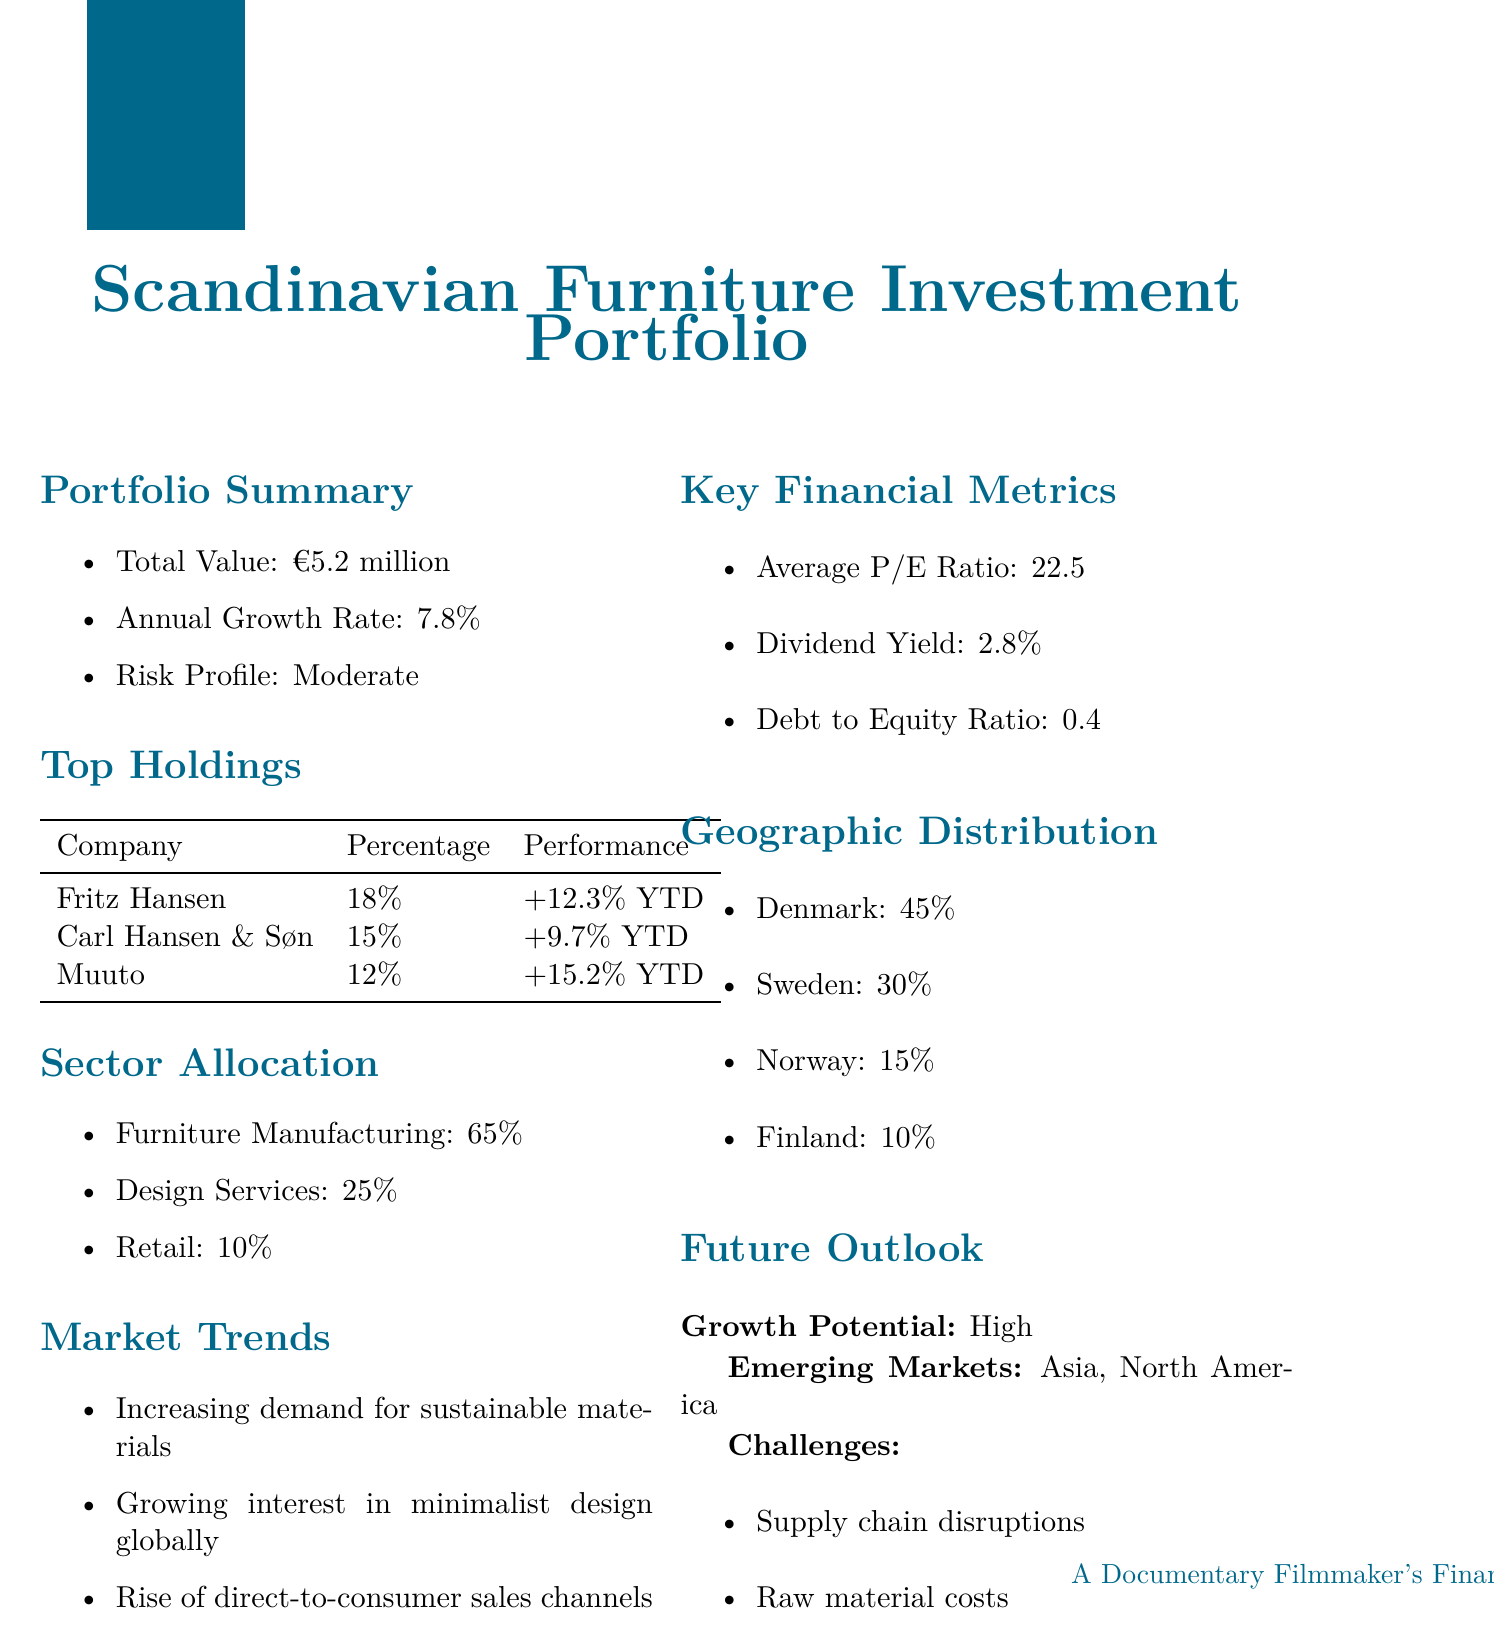What is the total value of the investment portfolio? The total value of the investment portfolio is explicitly stated in the document.
Answer: €5.2 million What is the annual growth rate? The annual growth rate is mentioned in the portfolio summary section of the document.
Answer: 7.8% Which company has the highest percentage holding? By reviewing the top holdings section, it is clear which company has the highest percentage.
Answer: Fritz Hansen What percentage of the portfolio is allocated to Furniture Manufacturing? The sector allocation section lists the percentage allocated to Furniture Manufacturing.
Answer: 65% What is the average P/E ratio? The average P/E ratio is provided in the key financial metrics section of the document.
Answer: 22.5 Which country has the lowest geographic distribution? The geographic distribution section provides the distribution percentages for each country.
Answer: Finland What challenges are mentioned in the future outlook? The document lists specific challenges that the investment portfolio might face in the future outlook section.
Answer: Supply chain disruptions What is the dividend yield? The dividend yield is included in the key financial metrics section of the document.
Answer: 2.8% Which emerging markets are identified in the future outlook? The future outlook section specifies the emerging markets that are considered important for growth.
Answer: Asia, North America 